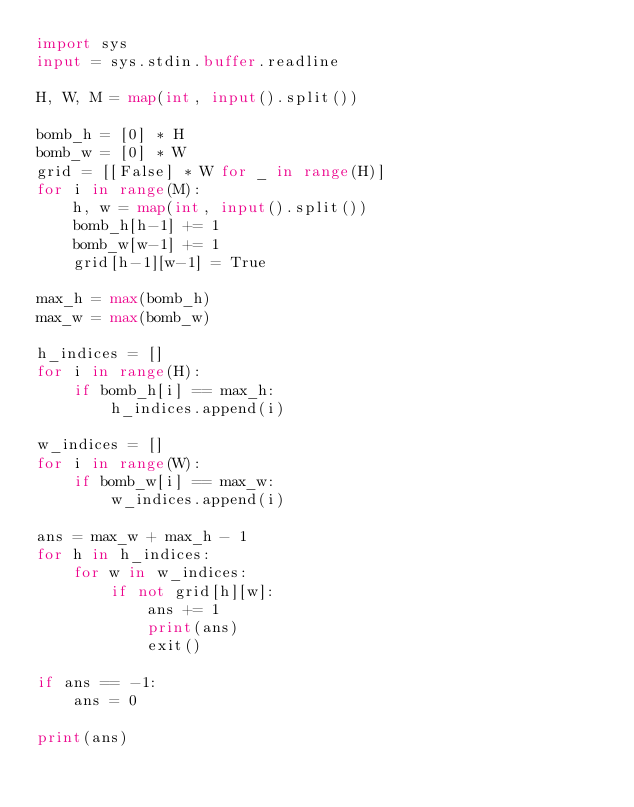<code> <loc_0><loc_0><loc_500><loc_500><_Python_>import sys
input = sys.stdin.buffer.readline

H, W, M = map(int, input().split())

bomb_h = [0] * H
bomb_w = [0] * W
grid = [[False] * W for _ in range(H)]
for i in range(M):
    h, w = map(int, input().split())
    bomb_h[h-1] += 1
    bomb_w[w-1] += 1
    grid[h-1][w-1] = True

max_h = max(bomb_h)
max_w = max(bomb_w)

h_indices = []
for i in range(H):
    if bomb_h[i] == max_h:
        h_indices.append(i)

w_indices = []
for i in range(W):
    if bomb_w[i] == max_w:
        w_indices.append(i)

ans = max_w + max_h - 1
for h in h_indices:
    for w in w_indices:
        if not grid[h][w]:
            ans += 1
            print(ans)
            exit()

if ans == -1:
    ans = 0

print(ans)
</code> 